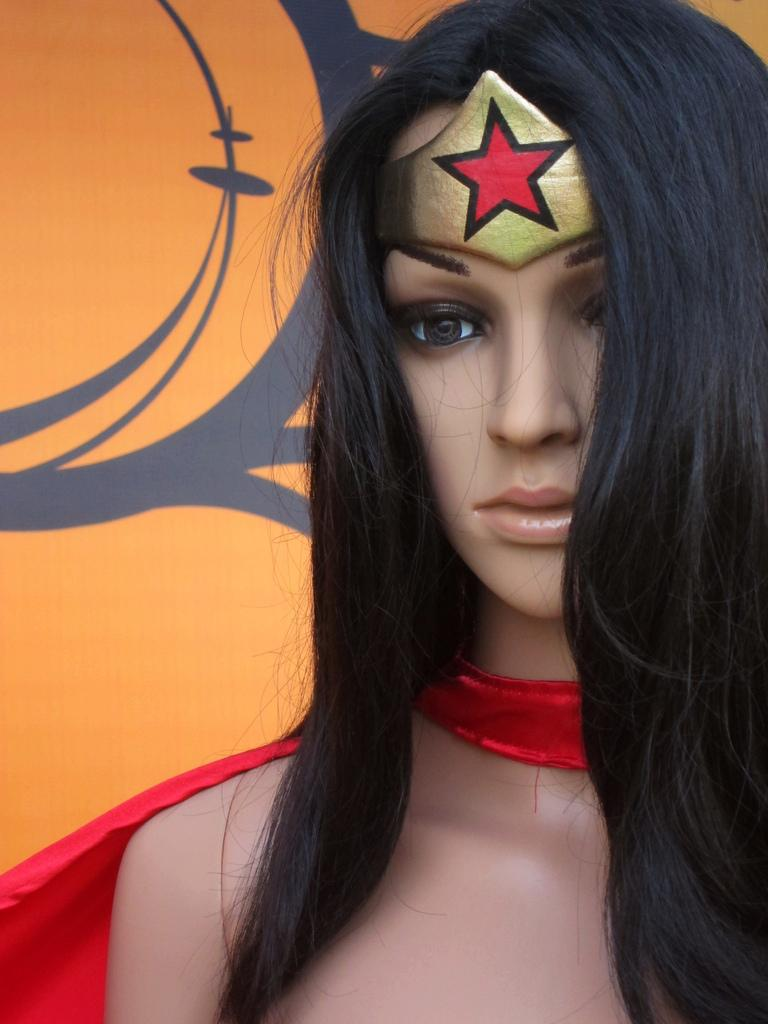What type of toy is in the image? There is a lady toy in the image. What is the lady toy wearing? The lady toy is wearing a costume. What can be seen in the background of the image? There is a background with some art in the image. How does the lady toy attempt to increase the number of brothers in the image? The lady toy does not attempt to increase the number of brothers in the image, as there is no mention of brothers in the provided facts. 